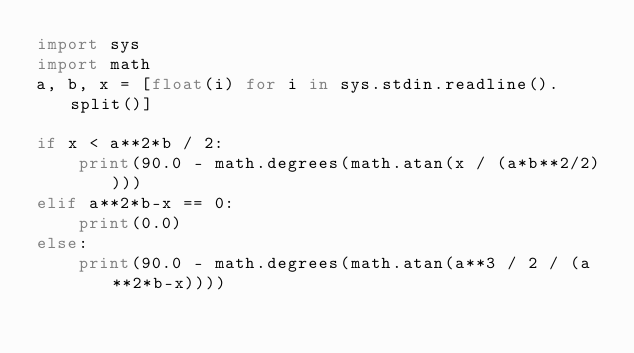<code> <loc_0><loc_0><loc_500><loc_500><_Python_>import sys
import math
a, b, x = [float(i) for i in sys.stdin.readline().split()]

if x < a**2*b / 2:
    print(90.0 - math.degrees(math.atan(x / (a*b**2/2))))
elif a**2*b-x == 0:
    print(0.0)
else:
    print(90.0 - math.degrees(math.atan(a**3 / 2 / (a**2*b-x))))</code> 